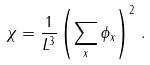<formula> <loc_0><loc_0><loc_500><loc_500>\chi = \frac { 1 } { L ^ { 3 } } \left ( \sum _ { x } \phi _ { x } \right ) ^ { 2 } \, .</formula> 